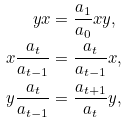<formula> <loc_0><loc_0><loc_500><loc_500>y x & = \frac { a _ { 1 } } { a _ { 0 } } x y , \\ x \frac { a _ { t } } { a _ { t - 1 } } & = \frac { a _ { t } } { a _ { t - 1 } } x , \\ y \frac { a _ { t } } { a _ { t - 1 } } & = \frac { a _ { t + 1 } } { a _ { t } } y ,</formula> 